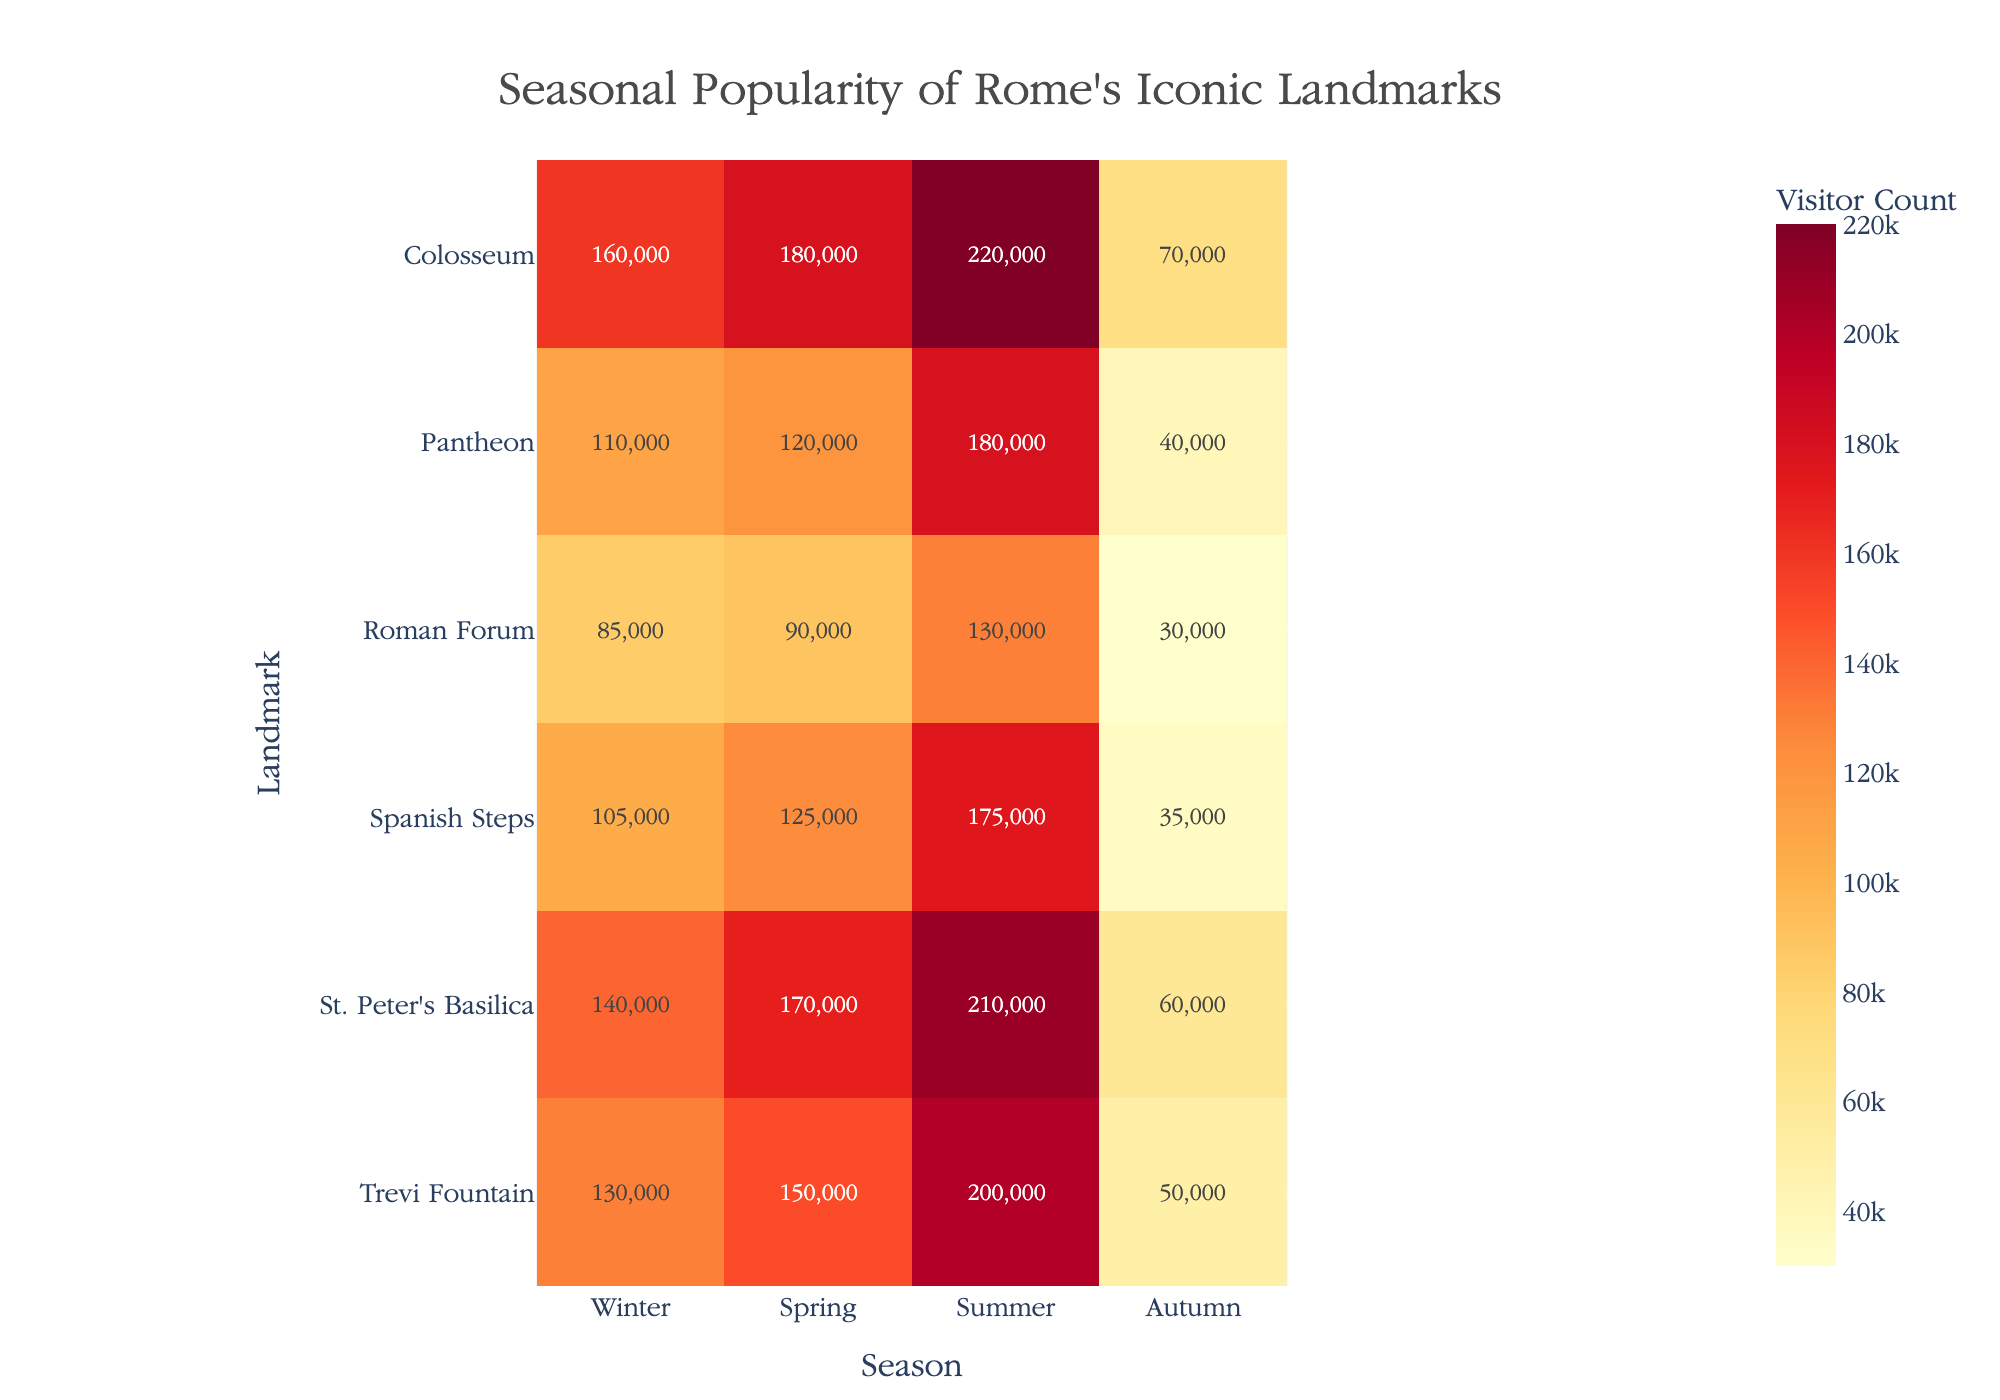What is the visitor count for the Colosseum during summer? Look at the intersection of 'Colosseum' row and 'Summer' column, the visitor count is shown within the heatmap cell.
Answer: 220,000 Which landmark had the highest visitor count in winter? Compare the values for 'Winter' across all landmarks; the highest value is located at St. Peter's Basilica.
Answer: St. Peter's Basilica What is the average visitor count for the Spanish Steps across all seasons? Sum the values for Spanish Steps: 35,000 (Winter) + 125,000 (Spring) + 175,000 (Summer) + 105,000 (Autumn) = 440,000. Then, divide by 4 (number of seasons).
Answer: 110,000 Which season has the highest total visitor count summed across all landmarks? Sum visitor counts for each season: Winter (245,000), Spring (835,000), Summer (1,115,000), Autumn (730,000). The highest total is in Summer.
Answer: Summer How much more popular is the Trevi Fountain in summer compared to winter? Subtract the winter visitor count from the summer visitor count for Trevi Fountain: 200,000 (Summer) - 50,000 (Winter).
Answer: 150,000 Compare the visitor counts for the Colosseum and the Pantheon in autumn. Which is higher and by how much? Subtract the Pantheon's autumn visitor count from the Colosseum's autumn visitor count: 160,000 (Colosseum) - 110,000 (Pantheon).
Answer: Colosseum, 50,000 What is the color scale used in the heatmap? The color scale transitions through shades of yellow, orange, and red to represent increasing visitor counts.
Answer: YlOrRd Is the visitor count for the Roman Forum in spring greater than the visitor count for the Pantheon in spring? Compare the values: Roman Forum Spring (90,000) and Pantheon Spring (120,000).
Answer: No Which landmark has the lowest visitor count in any season, and what is that count? Identify the minimum value within the heatmap cells; the lowest visitor count is the Roman Forum in Winter.
Answer: Roman Forum, 30,000 